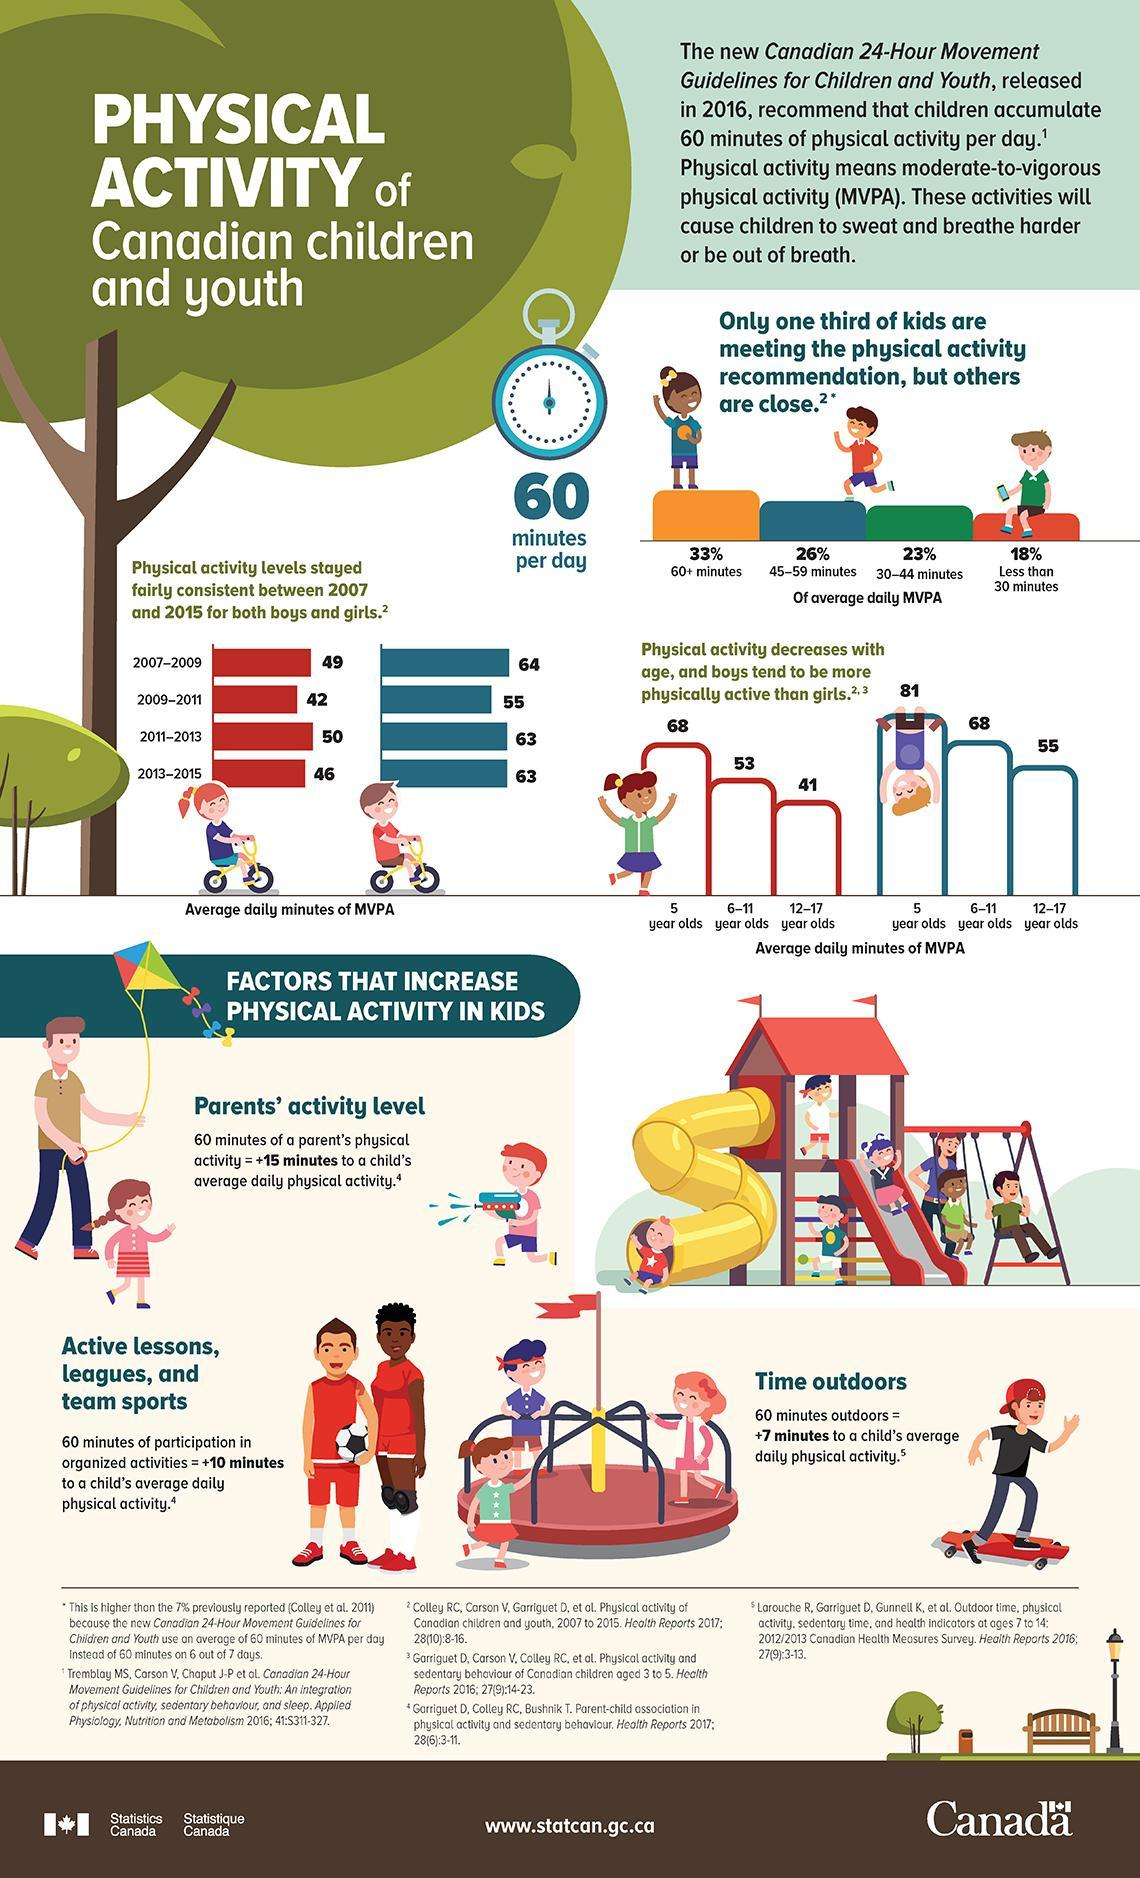How many more average daily minutes of MVPA do 5 year old boys have compared to girls who are 5 years old?
Answer the question with a short phrase. 13 How many more average daily minutes of MVPA do 12-17 year old boys have compared to girls who are 12-17 years old? 14 What is the difference in average daily minutes of MVPA between boys and girls in 2011-2013? 13 How many more average daily minutes of MVPA do 6-11 year old boys have compared to girls who are 6-11 years old? 15 What is the difference in average daily minutes of MVPA between boys and girls in 2007-2009? 15 What is the difference in average daily minutes of MVPA between boys and girls in 2013-2015? 17 What percentage of kids have average daily moderate-to-vigorous physical activity of less than 44 minutes? 41% What is the difference in average daily minutes of MVPA between boys and girls in 2009-2011? 13 